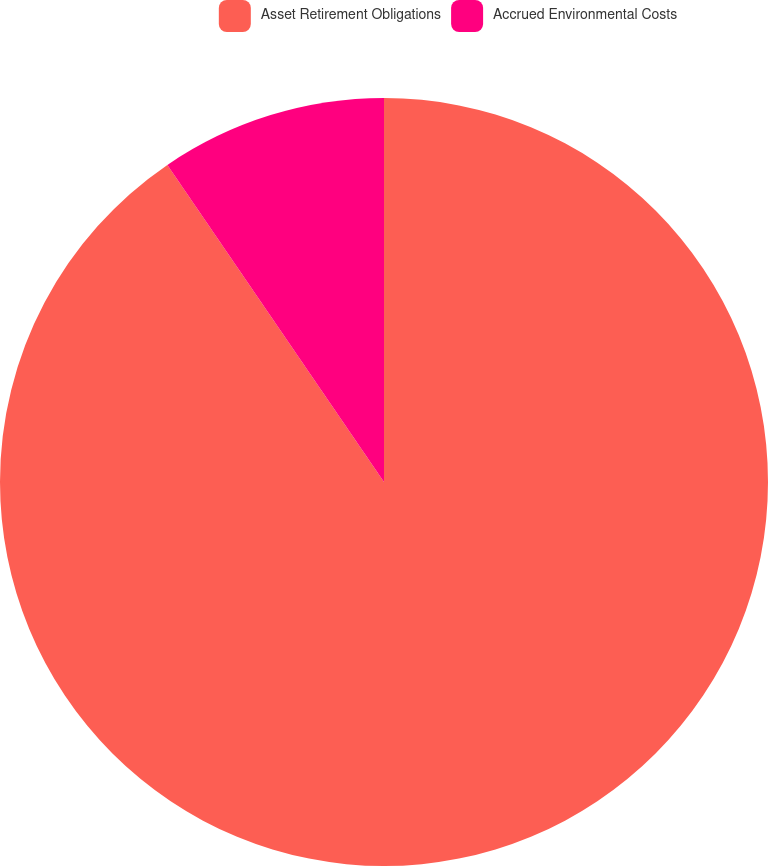Convert chart to OTSL. <chart><loc_0><loc_0><loc_500><loc_500><pie_chart><fcel>Asset Retirement Obligations<fcel>Accrued Environmental Costs<nl><fcel>90.46%<fcel>9.54%<nl></chart> 